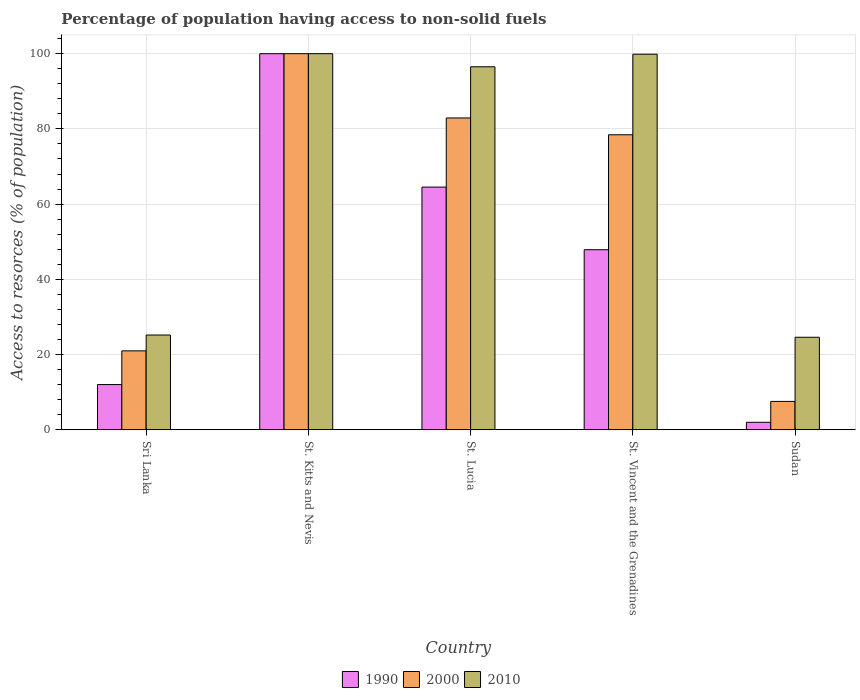How many different coloured bars are there?
Keep it short and to the point. 3. Are the number of bars per tick equal to the number of legend labels?
Provide a short and direct response. Yes. What is the label of the 2nd group of bars from the left?
Provide a short and direct response. St. Kitts and Nevis. What is the percentage of population having access to non-solid fuels in 2000 in St. Lucia?
Offer a very short reply. 82.91. Across all countries, what is the maximum percentage of population having access to non-solid fuels in 2010?
Ensure brevity in your answer.  100. Across all countries, what is the minimum percentage of population having access to non-solid fuels in 1990?
Your answer should be very brief. 2. In which country was the percentage of population having access to non-solid fuels in 1990 maximum?
Keep it short and to the point. St. Kitts and Nevis. In which country was the percentage of population having access to non-solid fuels in 2010 minimum?
Your response must be concise. Sudan. What is the total percentage of population having access to non-solid fuels in 1990 in the graph?
Ensure brevity in your answer.  226.44. What is the difference between the percentage of population having access to non-solid fuels in 2000 in St. Lucia and that in St. Vincent and the Grenadines?
Make the answer very short. 4.47. What is the difference between the percentage of population having access to non-solid fuels in 2010 in Sri Lanka and the percentage of population having access to non-solid fuels in 1990 in St. Kitts and Nevis?
Your answer should be compact. -74.8. What is the average percentage of population having access to non-solid fuels in 2000 per country?
Provide a succinct answer. 57.98. What is the difference between the percentage of population having access to non-solid fuels of/in 2010 and percentage of population having access to non-solid fuels of/in 1990 in Sudan?
Offer a terse response. 22.6. What is the ratio of the percentage of population having access to non-solid fuels in 1990 in St. Kitts and Nevis to that in Sudan?
Ensure brevity in your answer.  50. Is the difference between the percentage of population having access to non-solid fuels in 2010 in St. Lucia and St. Vincent and the Grenadines greater than the difference between the percentage of population having access to non-solid fuels in 1990 in St. Lucia and St. Vincent and the Grenadines?
Give a very brief answer. No. What is the difference between the highest and the second highest percentage of population having access to non-solid fuels in 2010?
Provide a succinct answer. -3.34. What is the difference between the highest and the lowest percentage of population having access to non-solid fuels in 2000?
Offer a very short reply. 92.45. What does the 2nd bar from the left in St. Vincent and the Grenadines represents?
Give a very brief answer. 2000. What does the 1st bar from the right in St. Kitts and Nevis represents?
Provide a succinct answer. 2010. How many bars are there?
Make the answer very short. 15. Are all the bars in the graph horizontal?
Provide a succinct answer. No. What is the difference between two consecutive major ticks on the Y-axis?
Offer a very short reply. 20. Are the values on the major ticks of Y-axis written in scientific E-notation?
Offer a terse response. No. Does the graph contain grids?
Provide a succinct answer. Yes. Where does the legend appear in the graph?
Provide a short and direct response. Bottom center. How many legend labels are there?
Your answer should be very brief. 3. What is the title of the graph?
Offer a terse response. Percentage of population having access to non-solid fuels. Does "1982" appear as one of the legend labels in the graph?
Your answer should be compact. No. What is the label or title of the X-axis?
Your answer should be very brief. Country. What is the label or title of the Y-axis?
Give a very brief answer. Access to resorces (% of population). What is the Access to resorces (% of population) in 1990 in Sri Lanka?
Ensure brevity in your answer.  12.03. What is the Access to resorces (% of population) of 2000 in Sri Lanka?
Give a very brief answer. 20.99. What is the Access to resorces (% of population) of 2010 in Sri Lanka?
Ensure brevity in your answer.  25.2. What is the Access to resorces (% of population) in 1990 in St. Kitts and Nevis?
Provide a short and direct response. 100. What is the Access to resorces (% of population) in 2000 in St. Kitts and Nevis?
Offer a very short reply. 100. What is the Access to resorces (% of population) in 1990 in St. Lucia?
Your answer should be very brief. 64.53. What is the Access to resorces (% of population) of 2000 in St. Lucia?
Provide a succinct answer. 82.91. What is the Access to resorces (% of population) in 2010 in St. Lucia?
Make the answer very short. 96.52. What is the Access to resorces (% of population) in 1990 in St. Vincent and the Grenadines?
Provide a succinct answer. 47.88. What is the Access to resorces (% of population) of 2000 in St. Vincent and the Grenadines?
Provide a short and direct response. 78.44. What is the Access to resorces (% of population) in 2010 in St. Vincent and the Grenadines?
Offer a very short reply. 99.86. What is the Access to resorces (% of population) of 1990 in Sudan?
Your answer should be very brief. 2. What is the Access to resorces (% of population) of 2000 in Sudan?
Provide a succinct answer. 7.55. What is the Access to resorces (% of population) of 2010 in Sudan?
Provide a succinct answer. 24.6. Across all countries, what is the maximum Access to resorces (% of population) in 2000?
Your answer should be very brief. 100. Across all countries, what is the minimum Access to resorces (% of population) in 1990?
Keep it short and to the point. 2. Across all countries, what is the minimum Access to resorces (% of population) in 2000?
Give a very brief answer. 7.55. Across all countries, what is the minimum Access to resorces (% of population) of 2010?
Offer a terse response. 24.6. What is the total Access to resorces (% of population) of 1990 in the graph?
Offer a very short reply. 226.44. What is the total Access to resorces (% of population) of 2000 in the graph?
Your answer should be very brief. 289.89. What is the total Access to resorces (% of population) of 2010 in the graph?
Provide a succinct answer. 346.18. What is the difference between the Access to resorces (% of population) of 1990 in Sri Lanka and that in St. Kitts and Nevis?
Offer a terse response. -87.97. What is the difference between the Access to resorces (% of population) in 2000 in Sri Lanka and that in St. Kitts and Nevis?
Offer a very short reply. -79.01. What is the difference between the Access to resorces (% of population) in 2010 in Sri Lanka and that in St. Kitts and Nevis?
Your answer should be compact. -74.8. What is the difference between the Access to resorces (% of population) in 1990 in Sri Lanka and that in St. Lucia?
Your response must be concise. -52.5. What is the difference between the Access to resorces (% of population) of 2000 in Sri Lanka and that in St. Lucia?
Ensure brevity in your answer.  -61.92. What is the difference between the Access to resorces (% of population) in 2010 in Sri Lanka and that in St. Lucia?
Your answer should be compact. -71.32. What is the difference between the Access to resorces (% of population) in 1990 in Sri Lanka and that in St. Vincent and the Grenadines?
Give a very brief answer. -35.85. What is the difference between the Access to resorces (% of population) of 2000 in Sri Lanka and that in St. Vincent and the Grenadines?
Make the answer very short. -57.45. What is the difference between the Access to resorces (% of population) in 2010 in Sri Lanka and that in St. Vincent and the Grenadines?
Give a very brief answer. -74.66. What is the difference between the Access to resorces (% of population) in 1990 in Sri Lanka and that in Sudan?
Your response must be concise. 10.03. What is the difference between the Access to resorces (% of population) of 2000 in Sri Lanka and that in Sudan?
Offer a terse response. 13.44. What is the difference between the Access to resorces (% of population) of 2010 in Sri Lanka and that in Sudan?
Keep it short and to the point. 0.59. What is the difference between the Access to resorces (% of population) in 1990 in St. Kitts and Nevis and that in St. Lucia?
Your answer should be compact. 35.47. What is the difference between the Access to resorces (% of population) of 2000 in St. Kitts and Nevis and that in St. Lucia?
Ensure brevity in your answer.  17.09. What is the difference between the Access to resorces (% of population) in 2010 in St. Kitts and Nevis and that in St. Lucia?
Keep it short and to the point. 3.48. What is the difference between the Access to resorces (% of population) in 1990 in St. Kitts and Nevis and that in St. Vincent and the Grenadines?
Give a very brief answer. 52.12. What is the difference between the Access to resorces (% of population) in 2000 in St. Kitts and Nevis and that in St. Vincent and the Grenadines?
Make the answer very short. 21.56. What is the difference between the Access to resorces (% of population) of 2010 in St. Kitts and Nevis and that in St. Vincent and the Grenadines?
Provide a short and direct response. 0.14. What is the difference between the Access to resorces (% of population) of 2000 in St. Kitts and Nevis and that in Sudan?
Provide a short and direct response. 92.45. What is the difference between the Access to resorces (% of population) of 2010 in St. Kitts and Nevis and that in Sudan?
Give a very brief answer. 75.4. What is the difference between the Access to resorces (% of population) in 1990 in St. Lucia and that in St. Vincent and the Grenadines?
Your answer should be very brief. 16.66. What is the difference between the Access to resorces (% of population) in 2000 in St. Lucia and that in St. Vincent and the Grenadines?
Your response must be concise. 4.47. What is the difference between the Access to resorces (% of population) in 2010 in St. Lucia and that in St. Vincent and the Grenadines?
Your answer should be compact. -3.34. What is the difference between the Access to resorces (% of population) in 1990 in St. Lucia and that in Sudan?
Ensure brevity in your answer.  62.53. What is the difference between the Access to resorces (% of population) of 2000 in St. Lucia and that in Sudan?
Provide a succinct answer. 75.36. What is the difference between the Access to resorces (% of population) in 2010 in St. Lucia and that in Sudan?
Provide a succinct answer. 71.91. What is the difference between the Access to resorces (% of population) in 1990 in St. Vincent and the Grenadines and that in Sudan?
Offer a very short reply. 45.88. What is the difference between the Access to resorces (% of population) in 2000 in St. Vincent and the Grenadines and that in Sudan?
Your response must be concise. 70.89. What is the difference between the Access to resorces (% of population) in 2010 in St. Vincent and the Grenadines and that in Sudan?
Ensure brevity in your answer.  75.26. What is the difference between the Access to resorces (% of population) of 1990 in Sri Lanka and the Access to resorces (% of population) of 2000 in St. Kitts and Nevis?
Make the answer very short. -87.97. What is the difference between the Access to resorces (% of population) in 1990 in Sri Lanka and the Access to resorces (% of population) in 2010 in St. Kitts and Nevis?
Your answer should be compact. -87.97. What is the difference between the Access to resorces (% of population) in 2000 in Sri Lanka and the Access to resorces (% of population) in 2010 in St. Kitts and Nevis?
Give a very brief answer. -79.01. What is the difference between the Access to resorces (% of population) in 1990 in Sri Lanka and the Access to resorces (% of population) in 2000 in St. Lucia?
Your answer should be very brief. -70.88. What is the difference between the Access to resorces (% of population) in 1990 in Sri Lanka and the Access to resorces (% of population) in 2010 in St. Lucia?
Your answer should be very brief. -84.49. What is the difference between the Access to resorces (% of population) in 2000 in Sri Lanka and the Access to resorces (% of population) in 2010 in St. Lucia?
Offer a terse response. -75.53. What is the difference between the Access to resorces (% of population) in 1990 in Sri Lanka and the Access to resorces (% of population) in 2000 in St. Vincent and the Grenadines?
Offer a very short reply. -66.41. What is the difference between the Access to resorces (% of population) of 1990 in Sri Lanka and the Access to resorces (% of population) of 2010 in St. Vincent and the Grenadines?
Keep it short and to the point. -87.83. What is the difference between the Access to resorces (% of population) in 2000 in Sri Lanka and the Access to resorces (% of population) in 2010 in St. Vincent and the Grenadines?
Make the answer very short. -78.87. What is the difference between the Access to resorces (% of population) in 1990 in Sri Lanka and the Access to resorces (% of population) in 2000 in Sudan?
Keep it short and to the point. 4.48. What is the difference between the Access to resorces (% of population) in 1990 in Sri Lanka and the Access to resorces (% of population) in 2010 in Sudan?
Offer a terse response. -12.57. What is the difference between the Access to resorces (% of population) of 2000 in Sri Lanka and the Access to resorces (% of population) of 2010 in Sudan?
Provide a short and direct response. -3.61. What is the difference between the Access to resorces (% of population) of 1990 in St. Kitts and Nevis and the Access to resorces (% of population) of 2000 in St. Lucia?
Your response must be concise. 17.09. What is the difference between the Access to resorces (% of population) of 1990 in St. Kitts and Nevis and the Access to resorces (% of population) of 2010 in St. Lucia?
Provide a short and direct response. 3.48. What is the difference between the Access to resorces (% of population) in 2000 in St. Kitts and Nevis and the Access to resorces (% of population) in 2010 in St. Lucia?
Offer a terse response. 3.48. What is the difference between the Access to resorces (% of population) in 1990 in St. Kitts and Nevis and the Access to resorces (% of population) in 2000 in St. Vincent and the Grenadines?
Ensure brevity in your answer.  21.56. What is the difference between the Access to resorces (% of population) of 1990 in St. Kitts and Nevis and the Access to resorces (% of population) of 2010 in St. Vincent and the Grenadines?
Give a very brief answer. 0.14. What is the difference between the Access to resorces (% of population) in 2000 in St. Kitts and Nevis and the Access to resorces (% of population) in 2010 in St. Vincent and the Grenadines?
Offer a very short reply. 0.14. What is the difference between the Access to resorces (% of population) in 1990 in St. Kitts and Nevis and the Access to resorces (% of population) in 2000 in Sudan?
Your answer should be very brief. 92.45. What is the difference between the Access to resorces (% of population) of 1990 in St. Kitts and Nevis and the Access to resorces (% of population) of 2010 in Sudan?
Give a very brief answer. 75.4. What is the difference between the Access to resorces (% of population) in 2000 in St. Kitts and Nevis and the Access to resorces (% of population) in 2010 in Sudan?
Provide a succinct answer. 75.4. What is the difference between the Access to resorces (% of population) of 1990 in St. Lucia and the Access to resorces (% of population) of 2000 in St. Vincent and the Grenadines?
Ensure brevity in your answer.  -13.91. What is the difference between the Access to resorces (% of population) in 1990 in St. Lucia and the Access to resorces (% of population) in 2010 in St. Vincent and the Grenadines?
Keep it short and to the point. -35.33. What is the difference between the Access to resorces (% of population) in 2000 in St. Lucia and the Access to resorces (% of population) in 2010 in St. Vincent and the Grenadines?
Make the answer very short. -16.95. What is the difference between the Access to resorces (% of population) of 1990 in St. Lucia and the Access to resorces (% of population) of 2000 in Sudan?
Offer a very short reply. 56.98. What is the difference between the Access to resorces (% of population) of 1990 in St. Lucia and the Access to resorces (% of population) of 2010 in Sudan?
Ensure brevity in your answer.  39.93. What is the difference between the Access to resorces (% of population) in 2000 in St. Lucia and the Access to resorces (% of population) in 2010 in Sudan?
Your answer should be very brief. 58.3. What is the difference between the Access to resorces (% of population) in 1990 in St. Vincent and the Grenadines and the Access to resorces (% of population) in 2000 in Sudan?
Offer a terse response. 40.33. What is the difference between the Access to resorces (% of population) in 1990 in St. Vincent and the Grenadines and the Access to resorces (% of population) in 2010 in Sudan?
Your answer should be compact. 23.27. What is the difference between the Access to resorces (% of population) in 2000 in St. Vincent and the Grenadines and the Access to resorces (% of population) in 2010 in Sudan?
Offer a terse response. 53.83. What is the average Access to resorces (% of population) in 1990 per country?
Provide a succinct answer. 45.29. What is the average Access to resorces (% of population) in 2000 per country?
Your response must be concise. 57.98. What is the average Access to resorces (% of population) of 2010 per country?
Your answer should be very brief. 69.24. What is the difference between the Access to resorces (% of population) of 1990 and Access to resorces (% of population) of 2000 in Sri Lanka?
Offer a very short reply. -8.96. What is the difference between the Access to resorces (% of population) of 1990 and Access to resorces (% of population) of 2010 in Sri Lanka?
Ensure brevity in your answer.  -13.17. What is the difference between the Access to resorces (% of population) in 2000 and Access to resorces (% of population) in 2010 in Sri Lanka?
Offer a very short reply. -4.21. What is the difference between the Access to resorces (% of population) in 1990 and Access to resorces (% of population) in 2010 in St. Kitts and Nevis?
Offer a very short reply. 0. What is the difference between the Access to resorces (% of population) of 1990 and Access to resorces (% of population) of 2000 in St. Lucia?
Make the answer very short. -18.38. What is the difference between the Access to resorces (% of population) of 1990 and Access to resorces (% of population) of 2010 in St. Lucia?
Your response must be concise. -31.99. What is the difference between the Access to resorces (% of population) in 2000 and Access to resorces (% of population) in 2010 in St. Lucia?
Give a very brief answer. -13.61. What is the difference between the Access to resorces (% of population) in 1990 and Access to resorces (% of population) in 2000 in St. Vincent and the Grenadines?
Ensure brevity in your answer.  -30.56. What is the difference between the Access to resorces (% of population) of 1990 and Access to resorces (% of population) of 2010 in St. Vincent and the Grenadines?
Provide a short and direct response. -51.99. What is the difference between the Access to resorces (% of population) in 2000 and Access to resorces (% of population) in 2010 in St. Vincent and the Grenadines?
Your response must be concise. -21.42. What is the difference between the Access to resorces (% of population) of 1990 and Access to resorces (% of population) of 2000 in Sudan?
Offer a very short reply. -5.55. What is the difference between the Access to resorces (% of population) in 1990 and Access to resorces (% of population) in 2010 in Sudan?
Your answer should be compact. -22.6. What is the difference between the Access to resorces (% of population) in 2000 and Access to resorces (% of population) in 2010 in Sudan?
Your response must be concise. -17.06. What is the ratio of the Access to resorces (% of population) of 1990 in Sri Lanka to that in St. Kitts and Nevis?
Offer a terse response. 0.12. What is the ratio of the Access to resorces (% of population) in 2000 in Sri Lanka to that in St. Kitts and Nevis?
Your answer should be very brief. 0.21. What is the ratio of the Access to resorces (% of population) of 2010 in Sri Lanka to that in St. Kitts and Nevis?
Your answer should be very brief. 0.25. What is the ratio of the Access to resorces (% of population) of 1990 in Sri Lanka to that in St. Lucia?
Your answer should be very brief. 0.19. What is the ratio of the Access to resorces (% of population) in 2000 in Sri Lanka to that in St. Lucia?
Your answer should be very brief. 0.25. What is the ratio of the Access to resorces (% of population) of 2010 in Sri Lanka to that in St. Lucia?
Your answer should be compact. 0.26. What is the ratio of the Access to resorces (% of population) in 1990 in Sri Lanka to that in St. Vincent and the Grenadines?
Your answer should be very brief. 0.25. What is the ratio of the Access to resorces (% of population) in 2000 in Sri Lanka to that in St. Vincent and the Grenadines?
Keep it short and to the point. 0.27. What is the ratio of the Access to resorces (% of population) of 2010 in Sri Lanka to that in St. Vincent and the Grenadines?
Your answer should be very brief. 0.25. What is the ratio of the Access to resorces (% of population) in 1990 in Sri Lanka to that in Sudan?
Ensure brevity in your answer.  6.01. What is the ratio of the Access to resorces (% of population) in 2000 in Sri Lanka to that in Sudan?
Give a very brief answer. 2.78. What is the ratio of the Access to resorces (% of population) of 2010 in Sri Lanka to that in Sudan?
Give a very brief answer. 1.02. What is the ratio of the Access to resorces (% of population) in 1990 in St. Kitts and Nevis to that in St. Lucia?
Keep it short and to the point. 1.55. What is the ratio of the Access to resorces (% of population) in 2000 in St. Kitts and Nevis to that in St. Lucia?
Give a very brief answer. 1.21. What is the ratio of the Access to resorces (% of population) of 2010 in St. Kitts and Nevis to that in St. Lucia?
Give a very brief answer. 1.04. What is the ratio of the Access to resorces (% of population) in 1990 in St. Kitts and Nevis to that in St. Vincent and the Grenadines?
Ensure brevity in your answer.  2.09. What is the ratio of the Access to resorces (% of population) of 2000 in St. Kitts and Nevis to that in St. Vincent and the Grenadines?
Your answer should be very brief. 1.27. What is the ratio of the Access to resorces (% of population) of 2010 in St. Kitts and Nevis to that in St. Vincent and the Grenadines?
Keep it short and to the point. 1. What is the ratio of the Access to resorces (% of population) of 1990 in St. Kitts and Nevis to that in Sudan?
Provide a succinct answer. 50. What is the ratio of the Access to resorces (% of population) in 2000 in St. Kitts and Nevis to that in Sudan?
Ensure brevity in your answer.  13.25. What is the ratio of the Access to resorces (% of population) in 2010 in St. Kitts and Nevis to that in Sudan?
Make the answer very short. 4.06. What is the ratio of the Access to resorces (% of population) of 1990 in St. Lucia to that in St. Vincent and the Grenadines?
Offer a very short reply. 1.35. What is the ratio of the Access to resorces (% of population) of 2000 in St. Lucia to that in St. Vincent and the Grenadines?
Make the answer very short. 1.06. What is the ratio of the Access to resorces (% of population) of 2010 in St. Lucia to that in St. Vincent and the Grenadines?
Provide a succinct answer. 0.97. What is the ratio of the Access to resorces (% of population) of 1990 in St. Lucia to that in Sudan?
Your answer should be very brief. 32.27. What is the ratio of the Access to resorces (% of population) of 2000 in St. Lucia to that in Sudan?
Offer a very short reply. 10.98. What is the ratio of the Access to resorces (% of population) of 2010 in St. Lucia to that in Sudan?
Your response must be concise. 3.92. What is the ratio of the Access to resorces (% of population) of 1990 in St. Vincent and the Grenadines to that in Sudan?
Your answer should be compact. 23.94. What is the ratio of the Access to resorces (% of population) of 2000 in St. Vincent and the Grenadines to that in Sudan?
Provide a short and direct response. 10.39. What is the ratio of the Access to resorces (% of population) of 2010 in St. Vincent and the Grenadines to that in Sudan?
Keep it short and to the point. 4.06. What is the difference between the highest and the second highest Access to resorces (% of population) in 1990?
Provide a succinct answer. 35.47. What is the difference between the highest and the second highest Access to resorces (% of population) of 2000?
Make the answer very short. 17.09. What is the difference between the highest and the second highest Access to resorces (% of population) of 2010?
Your response must be concise. 0.14. What is the difference between the highest and the lowest Access to resorces (% of population) of 2000?
Keep it short and to the point. 92.45. What is the difference between the highest and the lowest Access to resorces (% of population) in 2010?
Offer a very short reply. 75.4. 